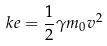Convert formula to latex. <formula><loc_0><loc_0><loc_500><loc_500>k e = \frac { 1 } { 2 } \gamma m _ { 0 } v ^ { 2 }</formula> 